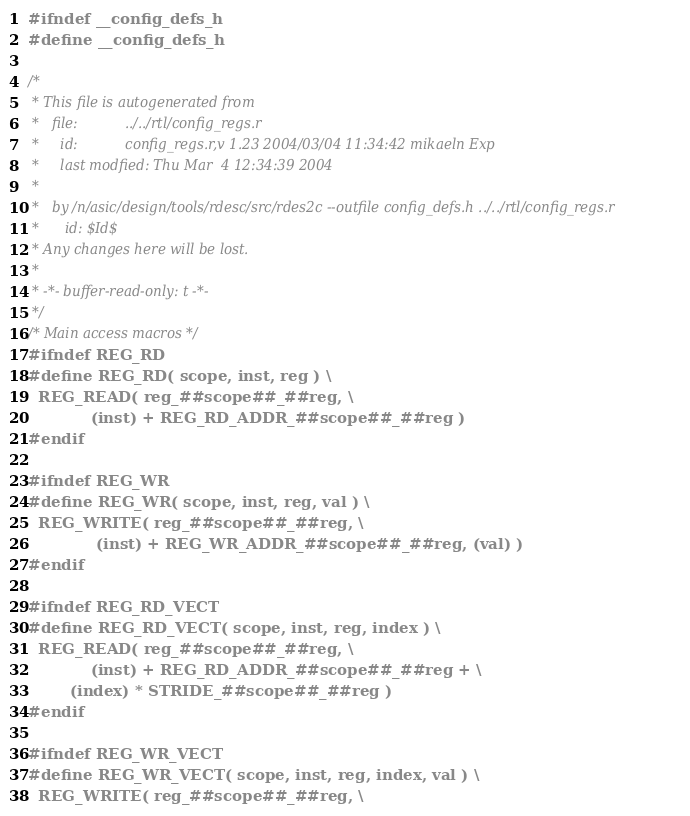Convert code to text. <code><loc_0><loc_0><loc_500><loc_500><_C_>#ifndef __config_defs_h
#define __config_defs_h

/*
 * This file is autogenerated from
 *   file:           ../../rtl/config_regs.r
 *     id:           config_regs.r,v 1.23 2004/03/04 11:34:42 mikaeln Exp 
 *     last modfied: Thu Mar  4 12:34:39 2004
 * 
 *   by /n/asic/design/tools/rdesc/src/rdes2c --outfile config_defs.h ../../rtl/config_regs.r
 *      id: $Id$
 * Any changes here will be lost.
 *
 * -*- buffer-read-only: t -*-
 */
/* Main access macros */
#ifndef REG_RD
#define REG_RD( scope, inst, reg ) \
  REG_READ( reg_##scope##_##reg, \
            (inst) + REG_RD_ADDR_##scope##_##reg )
#endif

#ifndef REG_WR
#define REG_WR( scope, inst, reg, val ) \
  REG_WRITE( reg_##scope##_##reg, \
             (inst) + REG_WR_ADDR_##scope##_##reg, (val) )
#endif

#ifndef REG_RD_VECT
#define REG_RD_VECT( scope, inst, reg, index ) \
  REG_READ( reg_##scope##_##reg, \
            (inst) + REG_RD_ADDR_##scope##_##reg + \
	    (index) * STRIDE_##scope##_##reg )
#endif

#ifndef REG_WR_VECT
#define REG_WR_VECT( scope, inst, reg, index, val ) \
  REG_WRITE( reg_##scope##_##reg, \</code> 